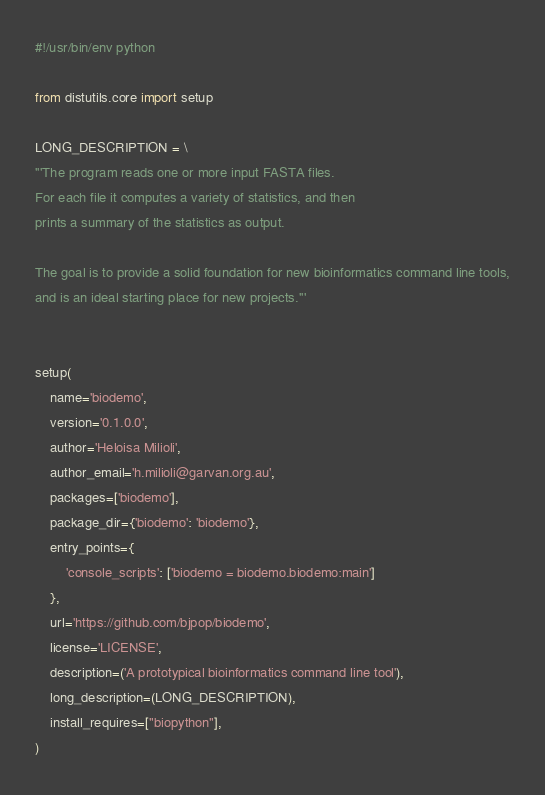<code> <loc_0><loc_0><loc_500><loc_500><_Python_>#!/usr/bin/env python

from distutils.core import setup

LONG_DESCRIPTION = \
'''The program reads one or more input FASTA files.
For each file it computes a variety of statistics, and then
prints a summary of the statistics as output.

The goal is to provide a solid foundation for new bioinformatics command line tools,
and is an ideal starting place for new projects.'''


setup(
    name='biodemo',
    version='0.1.0.0',
    author='Heloisa Milioli',
    author_email='h.milioli@garvan.org.au',
    packages=['biodemo'],
    package_dir={'biodemo': 'biodemo'},
    entry_points={
        'console_scripts': ['biodemo = biodemo.biodemo:main']
    },
    url='https://github.com/bjpop/biodemo',
    license='LICENSE',
    description=('A prototypical bioinformatics command line tool'),
    long_description=(LONG_DESCRIPTION),
    install_requires=["biopython"],
)
</code> 